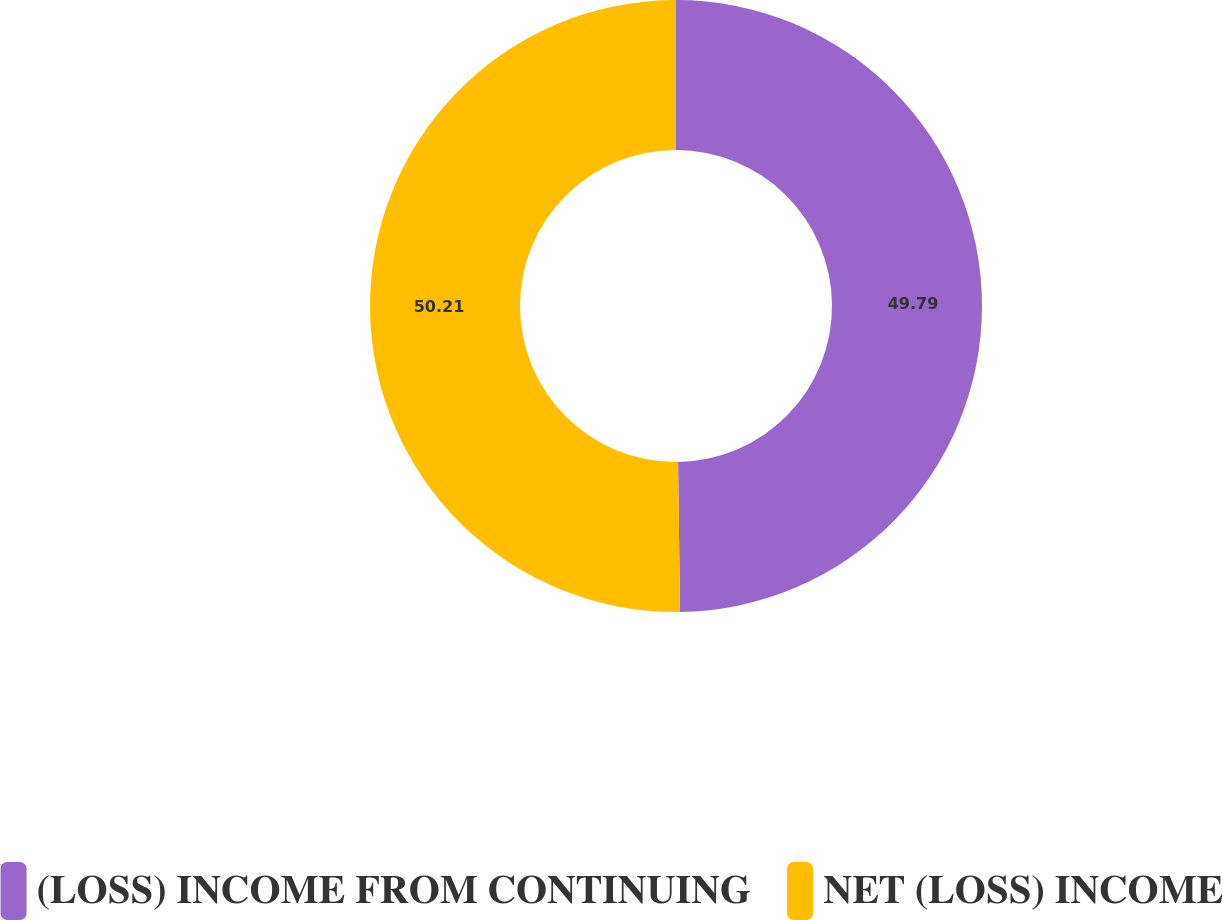<chart> <loc_0><loc_0><loc_500><loc_500><pie_chart><fcel>(LOSS) INCOME FROM CONTINUING<fcel>NET (LOSS) INCOME<nl><fcel>49.79%<fcel>50.21%<nl></chart> 